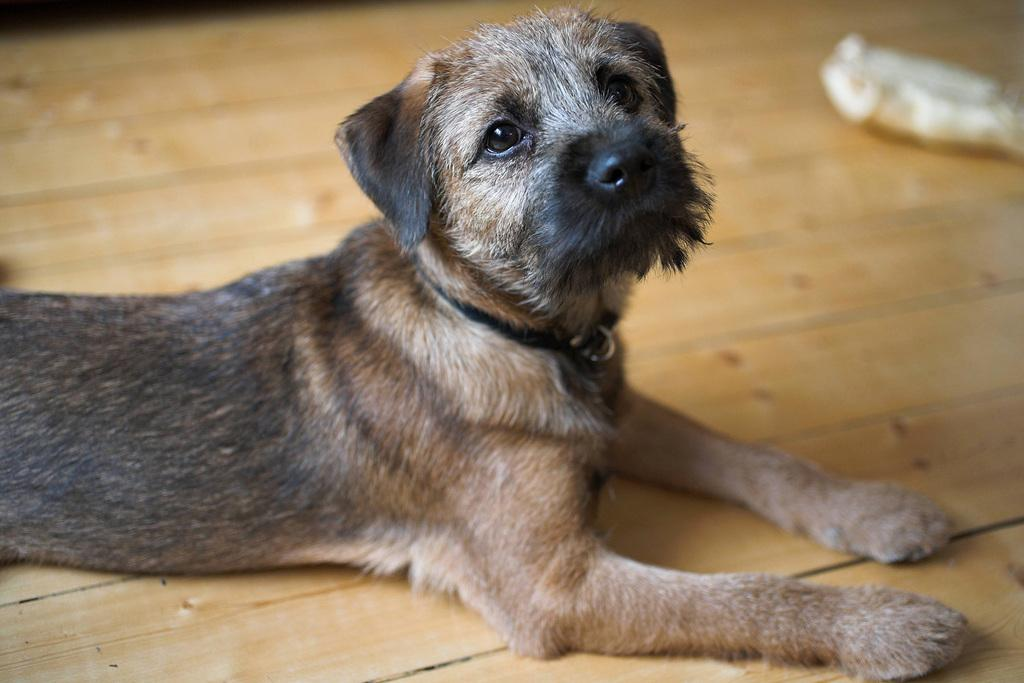What type of animal is present in the image? There is a dog in the image. What is the dog doing in the image? The dog is lying on the floor. What material is the floor made of? The floor is made of wood. What type of cloth is the dog using to embark on its journey in the image? There is no cloth or journey present in the image; it simply features a dog lying on a wooden floor. 